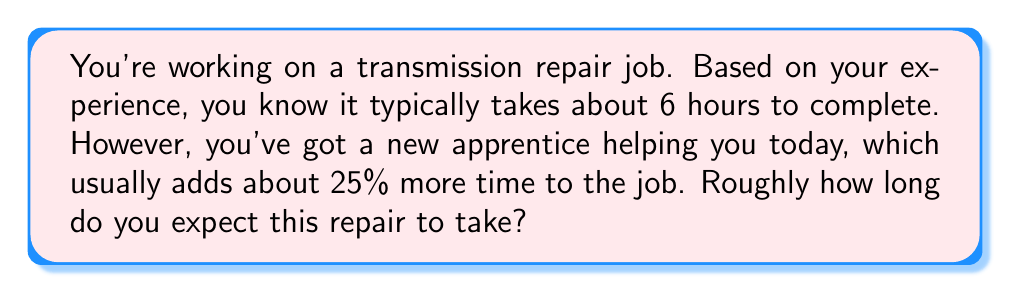Can you solve this math problem? Let's break this down step-by-step:

1. The normal time for the job is 6 hours.

2. With the apprentice, it takes 25% longer. To calculate this:
   - 25% is equivalent to 0.25 as a decimal
   - We need to increase the original time by this percentage

3. To increase a number by a percentage, we multiply by (1 + the percentage as a decimal):
   $$ \text{New Time} = \text{Original Time} \times (1 + 0.25) $$

4. Let's plug in the numbers:
   $$ \text{New Time} = 6 \times (1 + 0.25) = 6 \times 1.25 = 7.5 \text{ hours} $$

5. As a busy mechanic, you probably don't want to deal with decimal hours. Rounding up to the nearest whole hour gives us 8 hours.
Answer: The repair job is estimated to take approximately 8 hours. 